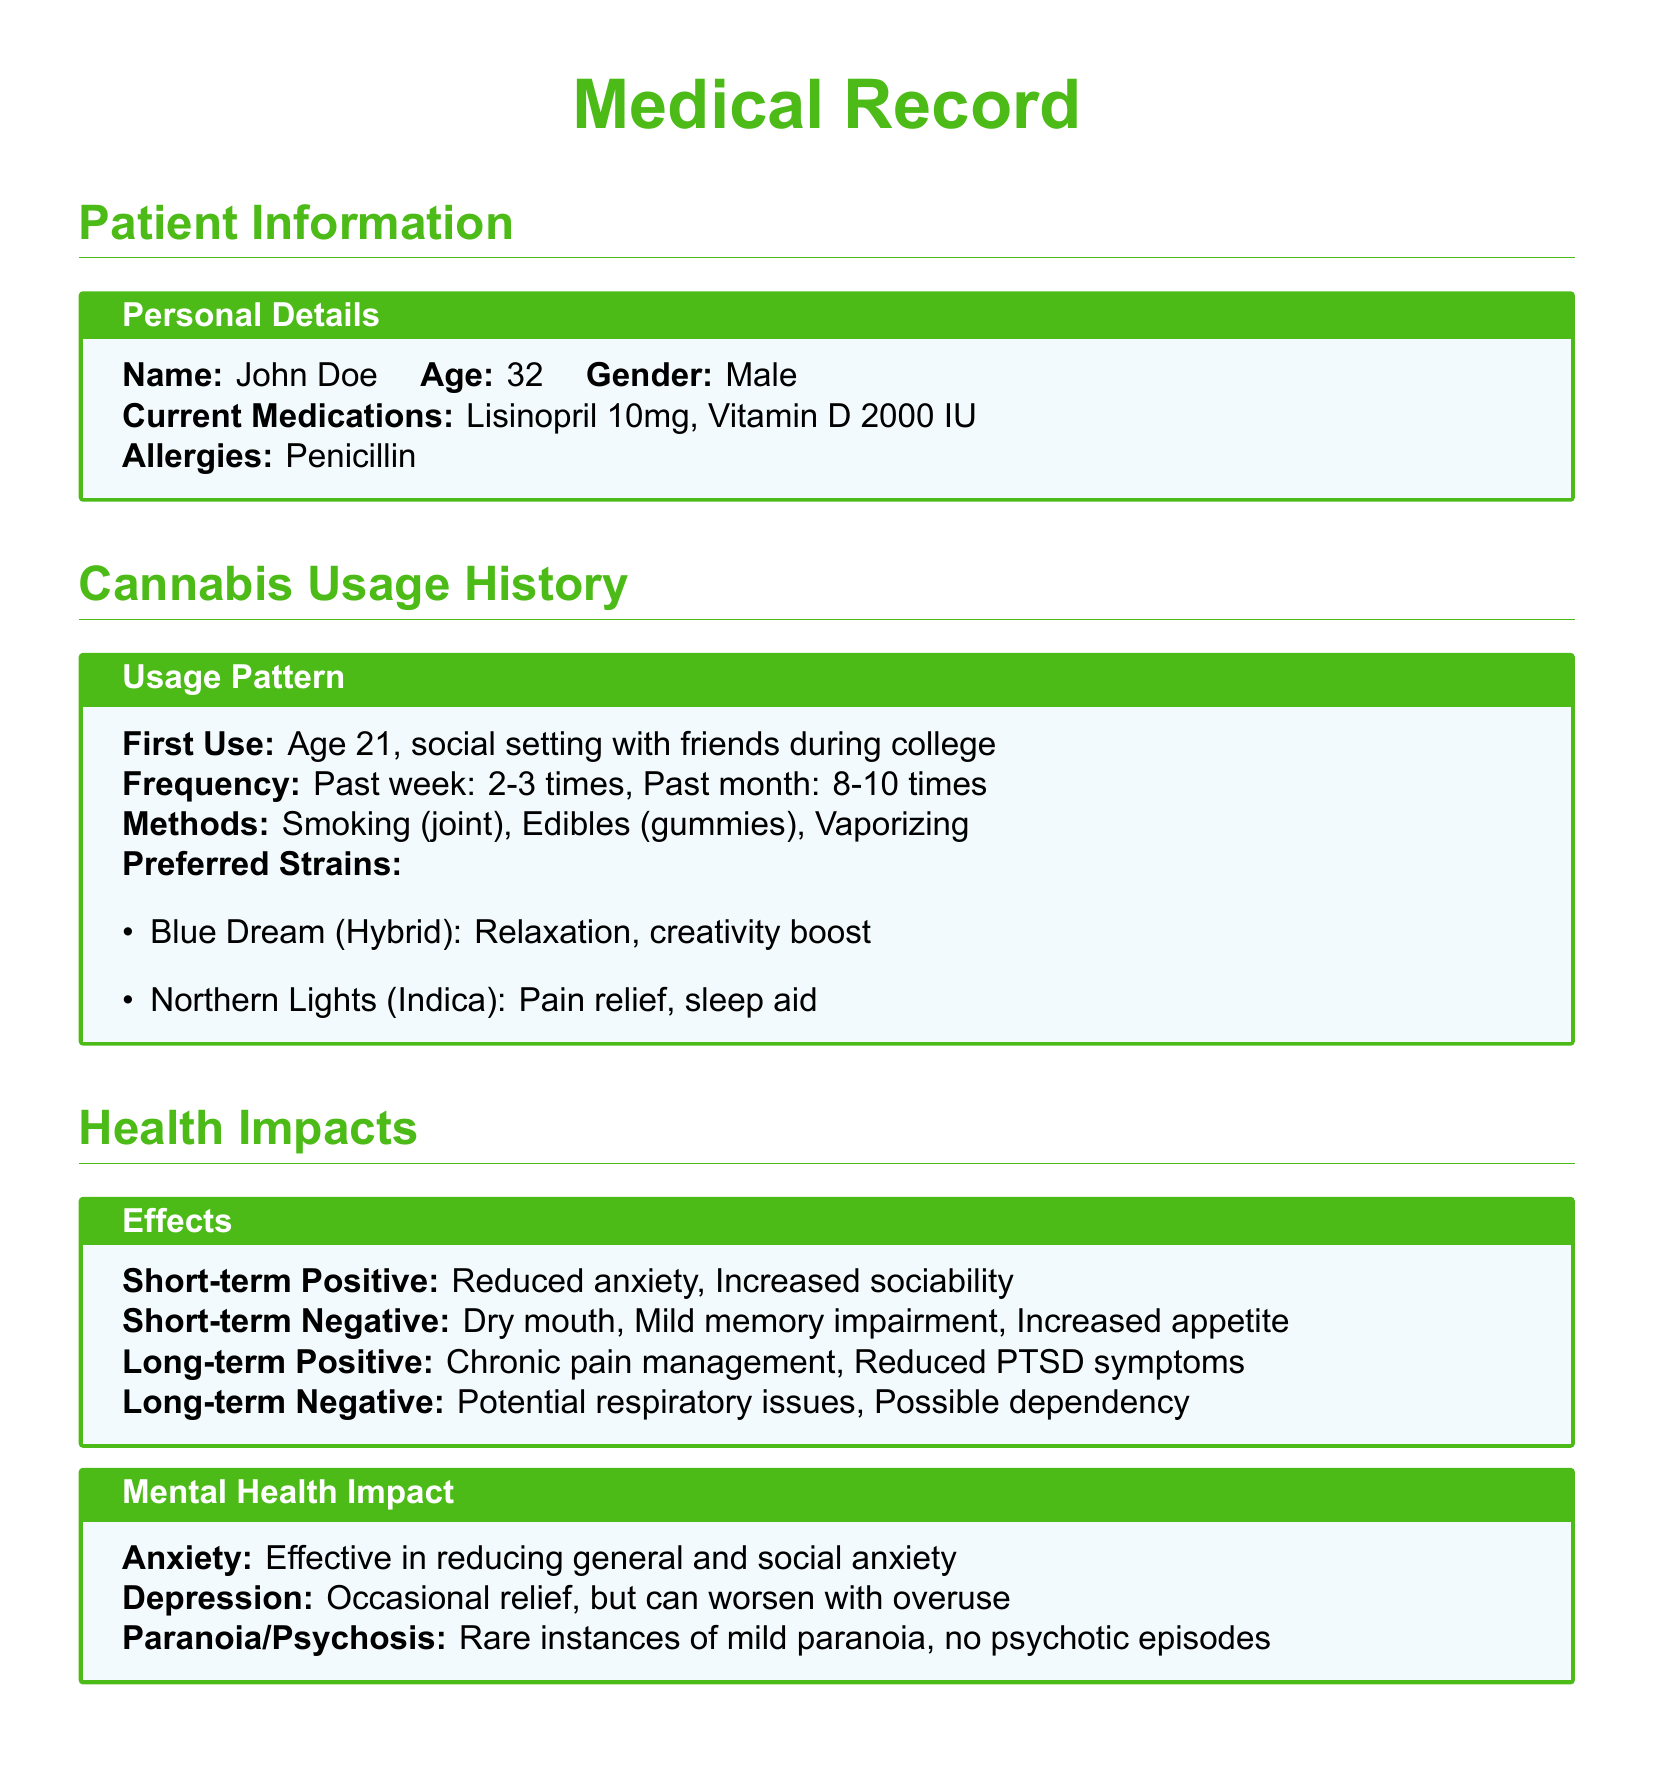What is the patient's name? The patient's name is listed in the Personal Details section of the document.
Answer: John Doe At what age did the patient first use cannabis? The patient's first use of cannabis is noted in the Usage History section.
Answer: Age 21 What is a short-term negative effect of cannabis usage? The document specifies several short-term negative effects in the Health Impacts section.
Answer: Dry mouth What methods does the patient use for cannabis consumption? The methods of consumption are detailed in the Cannabis Usage History section.
Answer: Smoking, Edibles, Vaporizing How many times did the patient use cannabis in the past week? The frequency of usage in the past week is provided in the Usage Pattern section.
Answer: 2-3 times What is one long-term positive impact of cannabis on health? The document outlines long-term positive impacts in the Health Impacts section.
Answer: Chronic pain management Is the patient currently on any medications? The Current Medications subsection lists medications for the patient.
Answer: Lisinopril 10mg, Vitamin D 2000 IU What should travelers check regarding cannabis before visiting a destination? The travel tips suggest a specific action regarding cannabis laws.
Answer: Local cannabis laws What is the recommended action if flying with cannabis? The Travel Tips section advises travelers on what to do regarding cannabis while flying.
Answer: Do not carry cannabis 